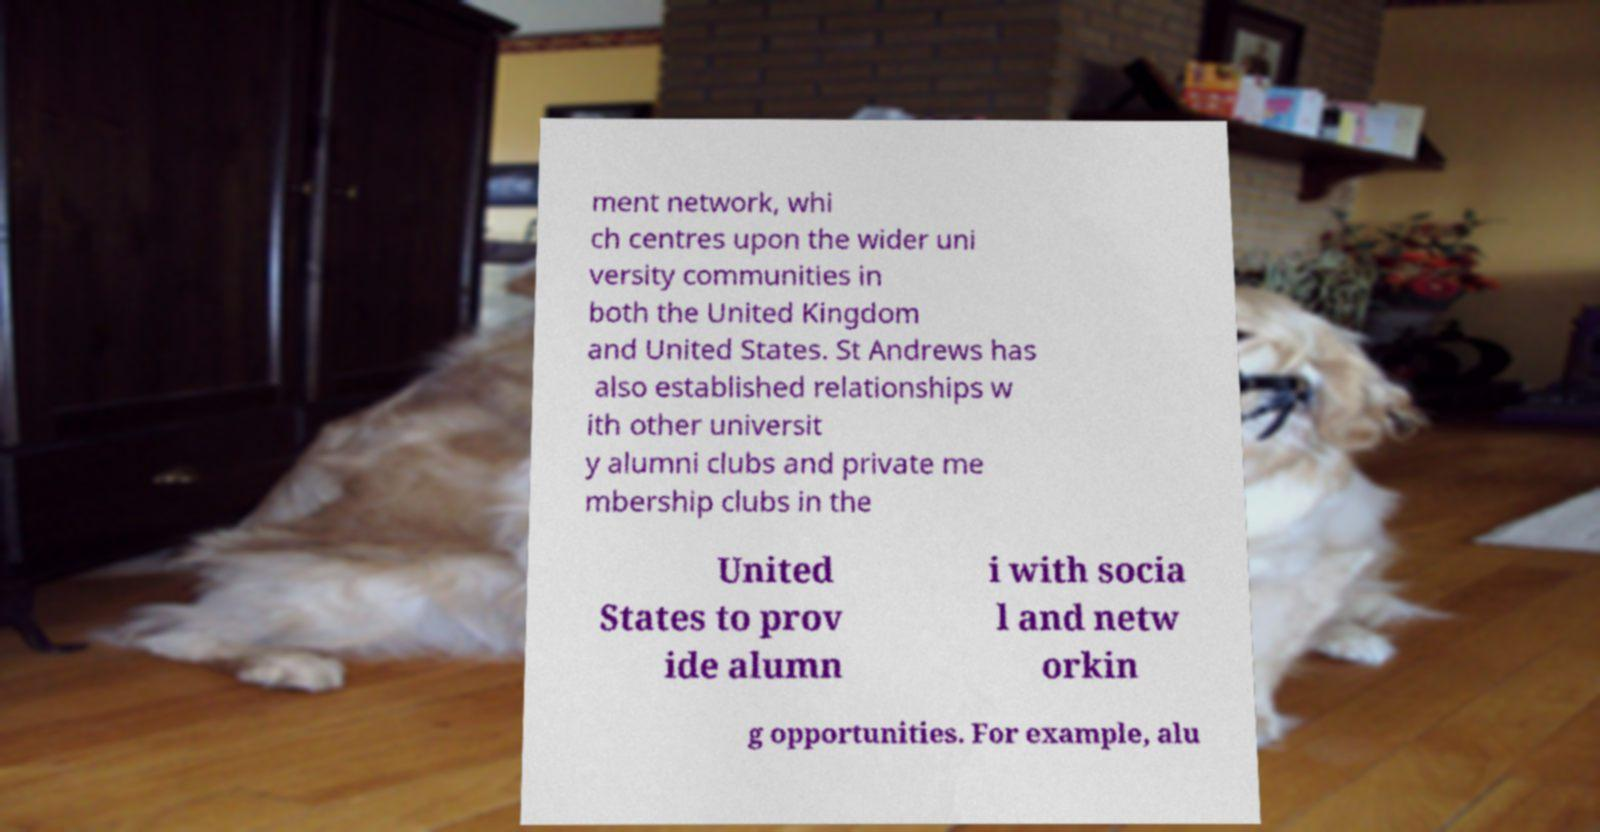Please identify and transcribe the text found in this image. ment network, whi ch centres upon the wider uni versity communities in both the United Kingdom and United States. St Andrews has also established relationships w ith other universit y alumni clubs and private me mbership clubs in the United States to prov ide alumn i with socia l and netw orkin g opportunities. For example, alu 